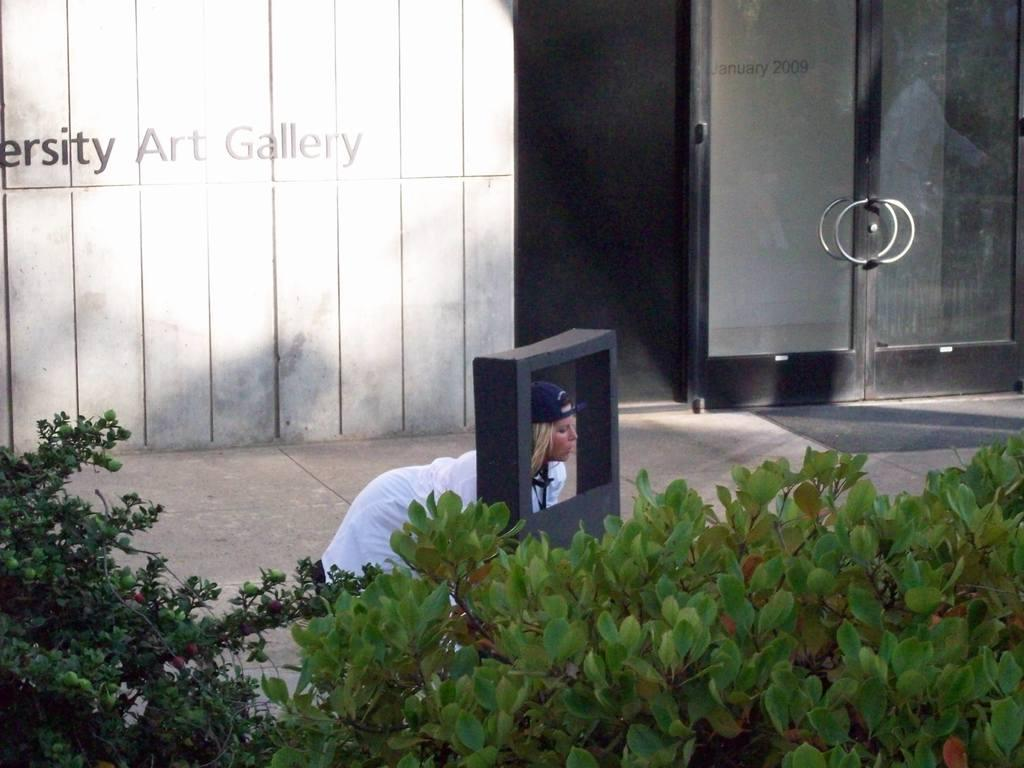Who is the main subject in the image? There is a woman in the image. What is the woman's position in the image? The woman is on the ground. What can be seen in the foreground of the image? There is a frame in the image. What type of vegetation is present in the image? There are plants in the image. What architectural feature is visible in the background of the image? There is a glass door with handles in the background. What is written on the wall in the background of the image? There is a wall with text on it in the background. How many nerves can be seen in the image? There are no nerves visible in the image. Is there a person other than the woman in the image? The image only features one person, the woman. What type of cakes are being served in the image? There are no cakes present in the image. 